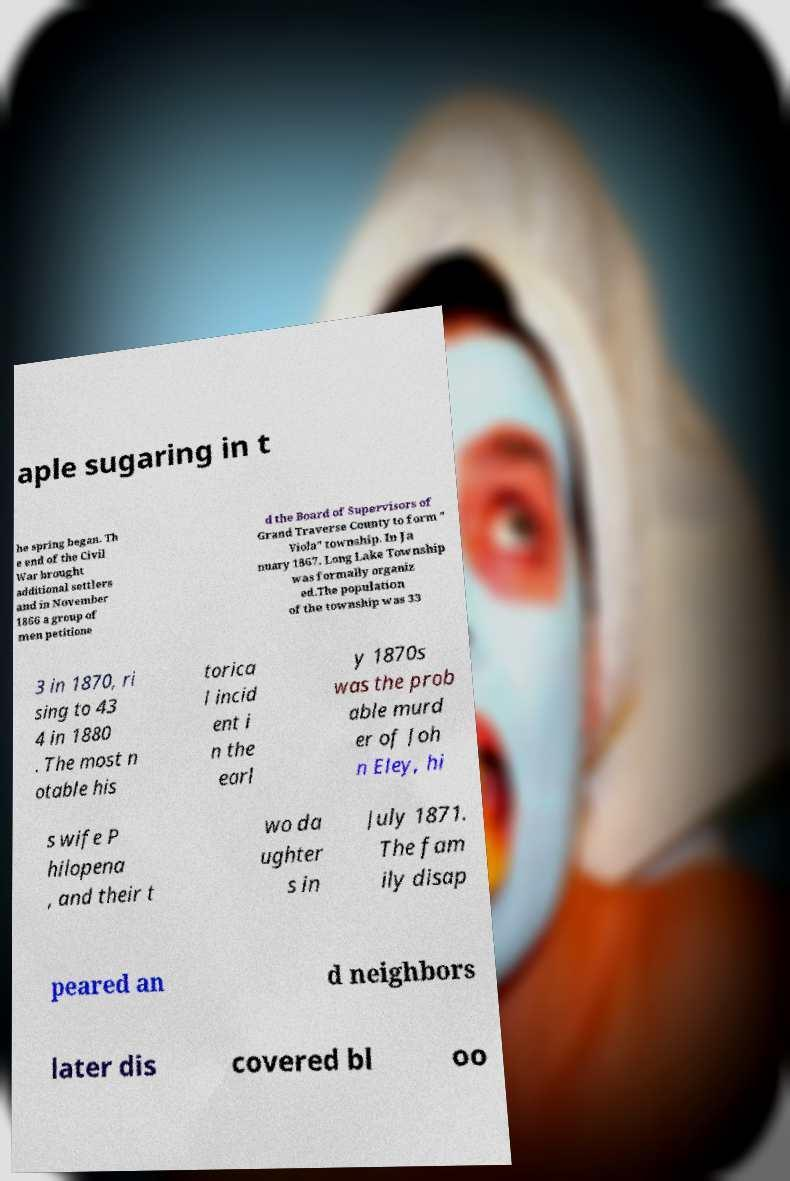Please read and relay the text visible in this image. What does it say? aple sugaring in t he spring began. Th e end of the Civil War brought additional settlers and in November 1866 a group of men petitione d the Board of Supervisors of Grand Traverse County to form " Viola" township. In Ja nuary 1867, Long Lake Township was formally organiz ed.The population of the township was 33 3 in 1870, ri sing to 43 4 in 1880 . The most n otable his torica l incid ent i n the earl y 1870s was the prob able murd er of Joh n Eley, hi s wife P hilopena , and their t wo da ughter s in July 1871. The fam ily disap peared an d neighbors later dis covered bl oo 